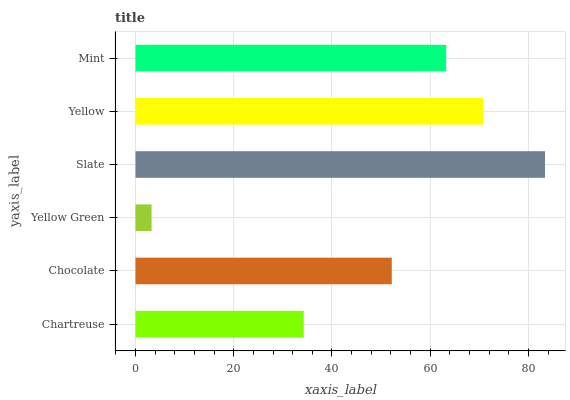Is Yellow Green the minimum?
Answer yes or no. Yes. Is Slate the maximum?
Answer yes or no. Yes. Is Chocolate the minimum?
Answer yes or no. No. Is Chocolate the maximum?
Answer yes or no. No. Is Chocolate greater than Chartreuse?
Answer yes or no. Yes. Is Chartreuse less than Chocolate?
Answer yes or no. Yes. Is Chartreuse greater than Chocolate?
Answer yes or no. No. Is Chocolate less than Chartreuse?
Answer yes or no. No. Is Mint the high median?
Answer yes or no. Yes. Is Chocolate the low median?
Answer yes or no. Yes. Is Yellow Green the high median?
Answer yes or no. No. Is Chartreuse the low median?
Answer yes or no. No. 